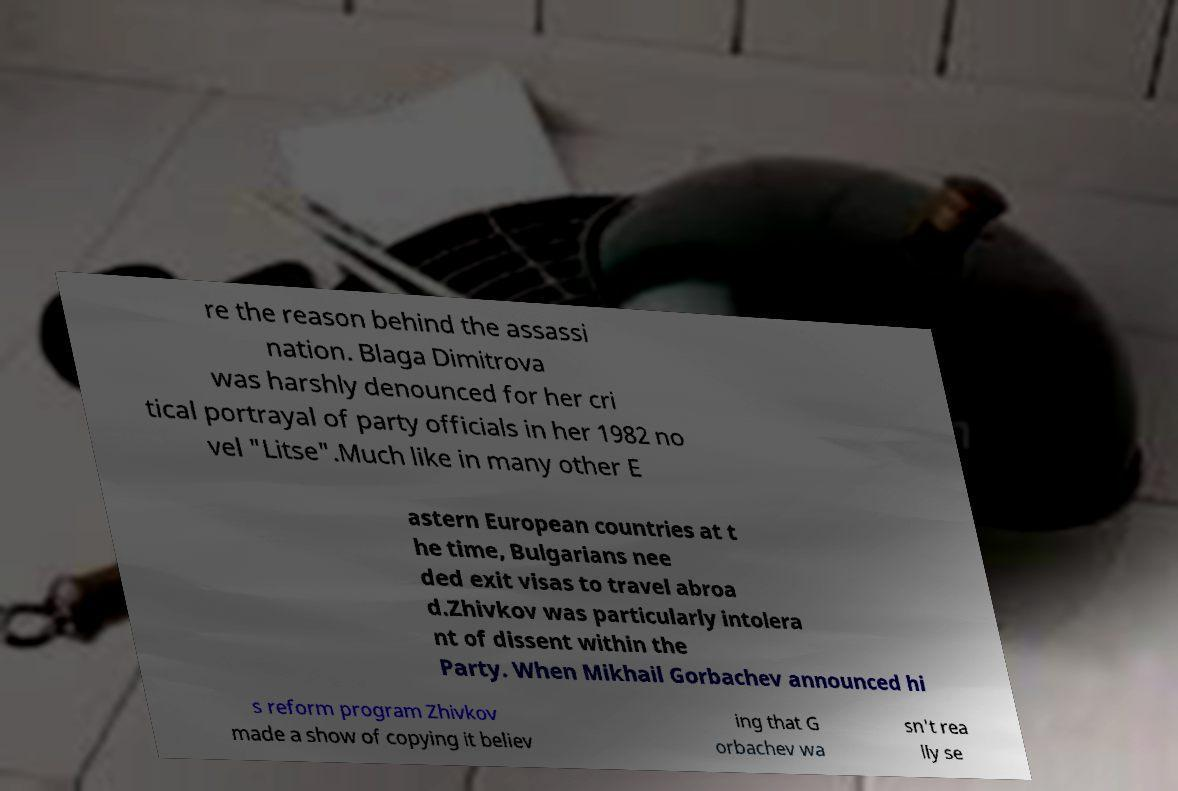What messages or text are displayed in this image? I need them in a readable, typed format. re the reason behind the assassi nation. Blaga Dimitrova was harshly denounced for her cri tical portrayal of party officials in her 1982 no vel "Litse".Much like in many other E astern European countries at t he time, Bulgarians nee ded exit visas to travel abroa d.Zhivkov was particularly intolera nt of dissent within the Party. When Mikhail Gorbachev announced hi s reform program Zhivkov made a show of copying it believ ing that G orbachev wa sn't rea lly se 